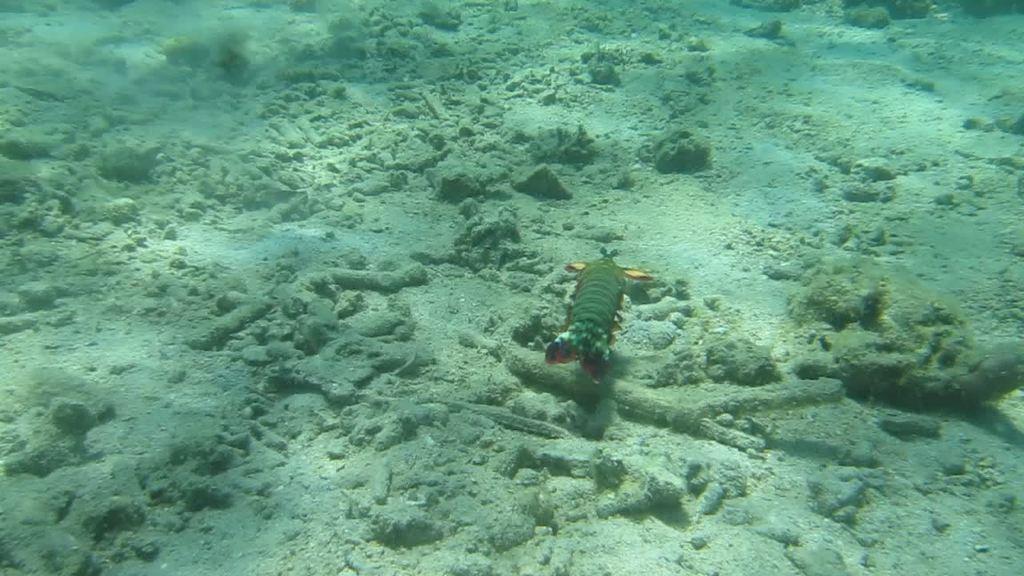In one or two sentences, can you explain what this image depicts? In the center of the image we can see a fish in the water. 